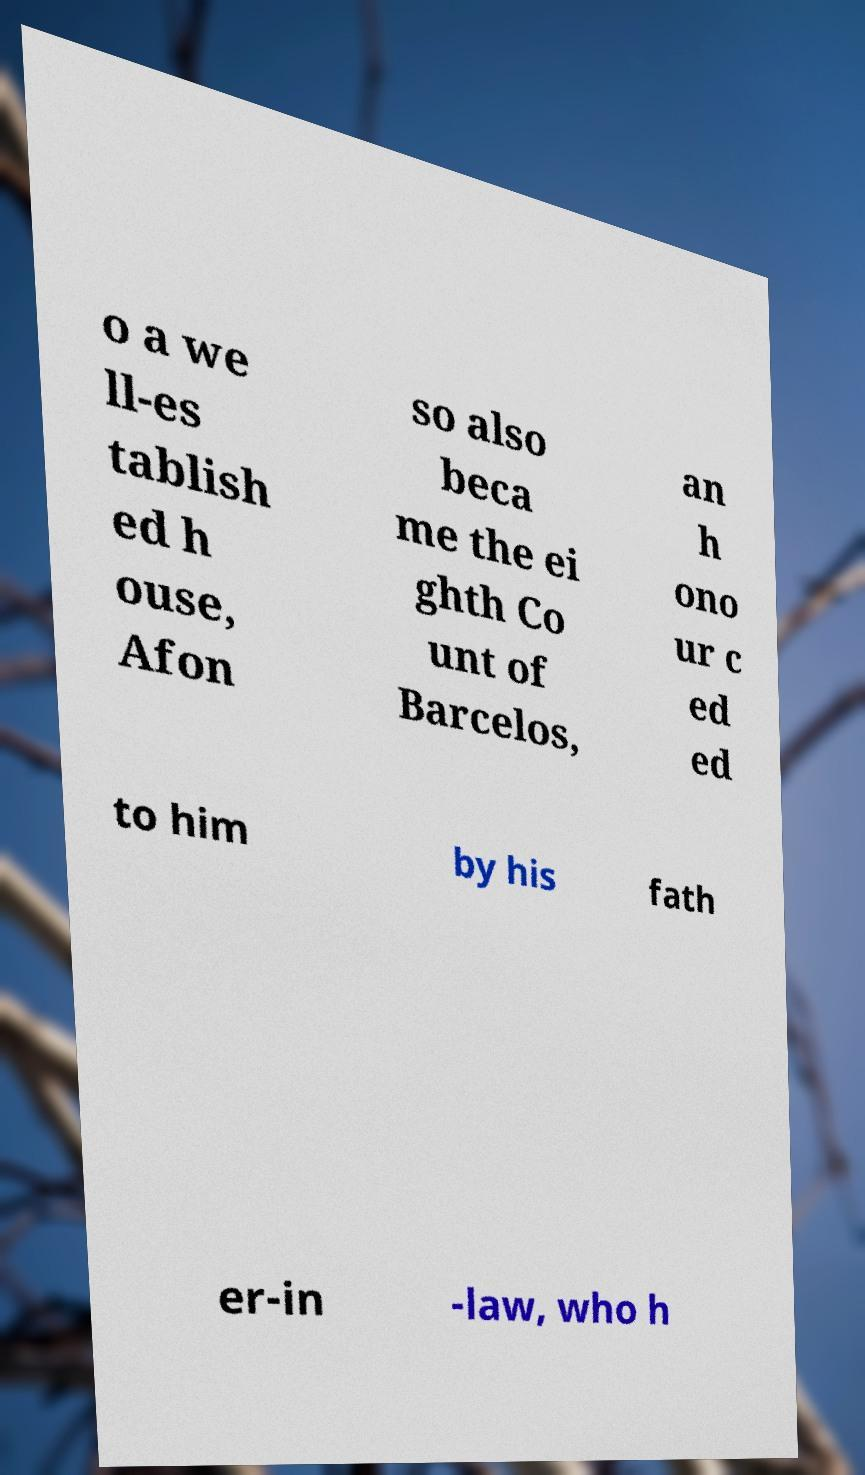I need the written content from this picture converted into text. Can you do that? o a we ll-es tablish ed h ouse, Afon so also beca me the ei ghth Co unt of Barcelos, an h ono ur c ed ed to him by his fath er-in -law, who h 